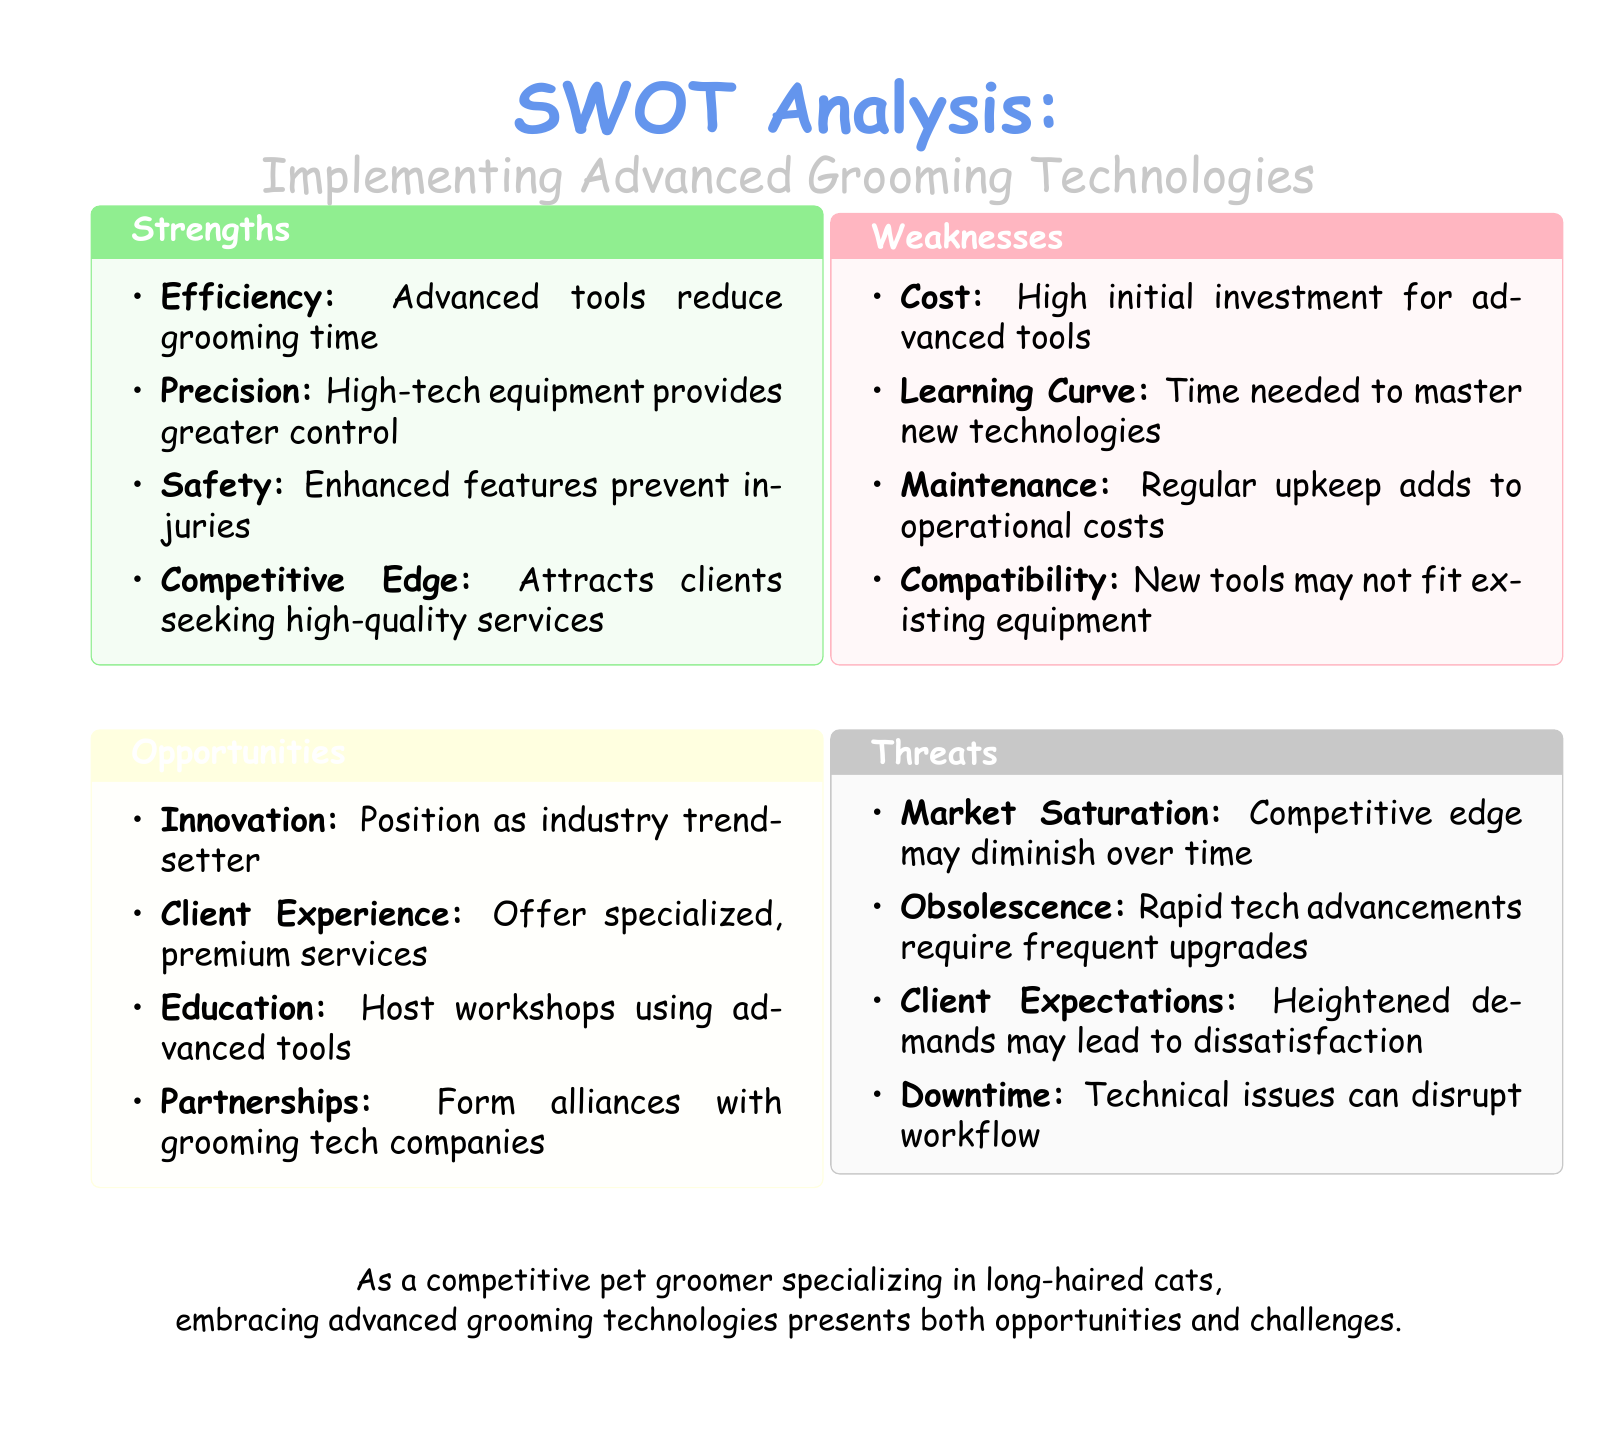What are two strengths of advanced grooming technologies? The strengths listed include efficiency and precision, among others.
Answer: Efficiency, Precision What is a potential opportunity mentioned for grooming businesses? The document highlights innovation as a way to position as an industry trendsetter.
Answer: Innovation What is one weakness related to advanced tools? The document specifies that high initial investment is a weakness.
Answer: Cost What could be a threat caused by rapid technological advancements? It states that rapid tech advancements require frequent upgrades, which is a threat.
Answer: Obsolescence How many aspects are described in the SWOT analysis? The document outlines four aspects: strengths, weaknesses, opportunities, and threats.
Answer: Four 